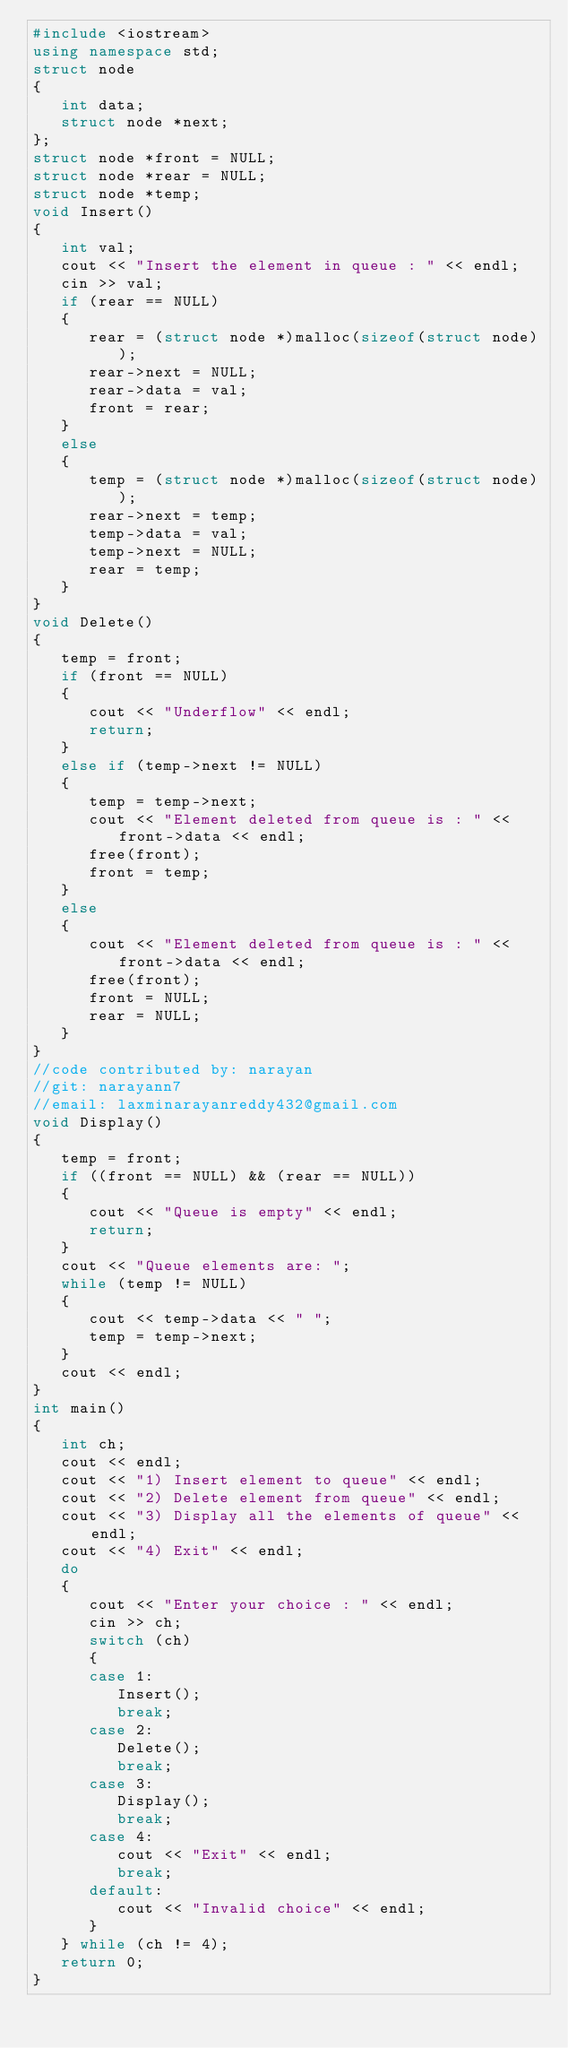<code> <loc_0><loc_0><loc_500><loc_500><_C++_>#include <iostream>
using namespace std;
struct node
{
   int data;
   struct node *next;
};
struct node *front = NULL;
struct node *rear = NULL;
struct node *temp;
void Insert()
{
   int val;
   cout << "Insert the element in queue : " << endl;
   cin >> val;
   if (rear == NULL)
   {
      rear = (struct node *)malloc(sizeof(struct node));
      rear->next = NULL;
      rear->data = val;
      front = rear;
   }
   else
   {
      temp = (struct node *)malloc(sizeof(struct node));
      rear->next = temp;
      temp->data = val;
      temp->next = NULL;
      rear = temp;
   }
}
void Delete()
{
   temp = front;
   if (front == NULL)
   {
      cout << "Underflow" << endl;
      return;
   }
   else if (temp->next != NULL)
   {
      temp = temp->next;
      cout << "Element deleted from queue is : " << front->data << endl;
      free(front);
      front = temp;
   }
   else
   {
      cout << "Element deleted from queue is : " << front->data << endl;
      free(front);
      front = NULL;
      rear = NULL;
   }
}
//code contributed by: narayan
//git: narayann7
//email: laxminarayanreddy432@gmail.com
void Display()
{
   temp = front;
   if ((front == NULL) && (rear == NULL))
   {
      cout << "Queue is empty" << endl;
      return;
   }
   cout << "Queue elements are: ";
   while (temp != NULL)
   {
      cout << temp->data << " ";
      temp = temp->next;
   }
   cout << endl;
}
int main()
{
   int ch;
   cout << endl;
   cout << "1) Insert element to queue" << endl;
   cout << "2) Delete element from queue" << endl;
   cout << "3) Display all the elements of queue" << endl;
   cout << "4) Exit" << endl;
   do
   {
      cout << "Enter your choice : " << endl;
      cin >> ch;
      switch (ch)
      {
      case 1:
         Insert();
         break;
      case 2:
         Delete();
         break;
      case 3:
         Display();
         break;
      case 4:
         cout << "Exit" << endl;
         break;
      default:
         cout << "Invalid choice" << endl;
      }
   } while (ch != 4);
   return 0;
}
</code> 